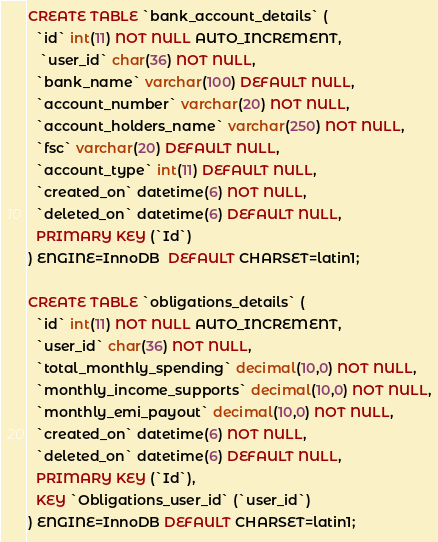<code> <loc_0><loc_0><loc_500><loc_500><_SQL_>CREATE TABLE `bank_account_details` (
  `id` int(11) NOT NULL AUTO_INCREMENT,
   `user_id` char(36) NOT NULL,
  `bank_name` varchar(100) DEFAULT NULL,
  `account_number` varchar(20) NOT NULL,
  `account_holders_name` varchar(250) NOT NULL,
  `fsc` varchar(20) DEFAULT NULL,
  `account_type` int(11) DEFAULT NULL,
  `created_on` datetime(6) NOT NULL,
  `deleted_on` datetime(6) DEFAULT NULL,
  PRIMARY KEY (`Id`)
) ENGINE=InnoDB  DEFAULT CHARSET=latin1;

CREATE TABLE `obligations_details` (
  `id` int(11) NOT NULL AUTO_INCREMENT,
  `user_id` char(36) NOT NULL,
  `total_monthly_spending` decimal(10,0) NOT NULL,
  `monthly_income_supports` decimal(10,0) NOT NULL,
  `monthly_emi_payout` decimal(10,0) NOT NULL,
  `created_on` datetime(6) NOT NULL,
  `deleted_on` datetime(6) DEFAULT NULL,
  PRIMARY KEY (`Id`),
  KEY `Obligations_user_id` (`user_id`)
) ENGINE=InnoDB DEFAULT CHARSET=latin1;</code> 